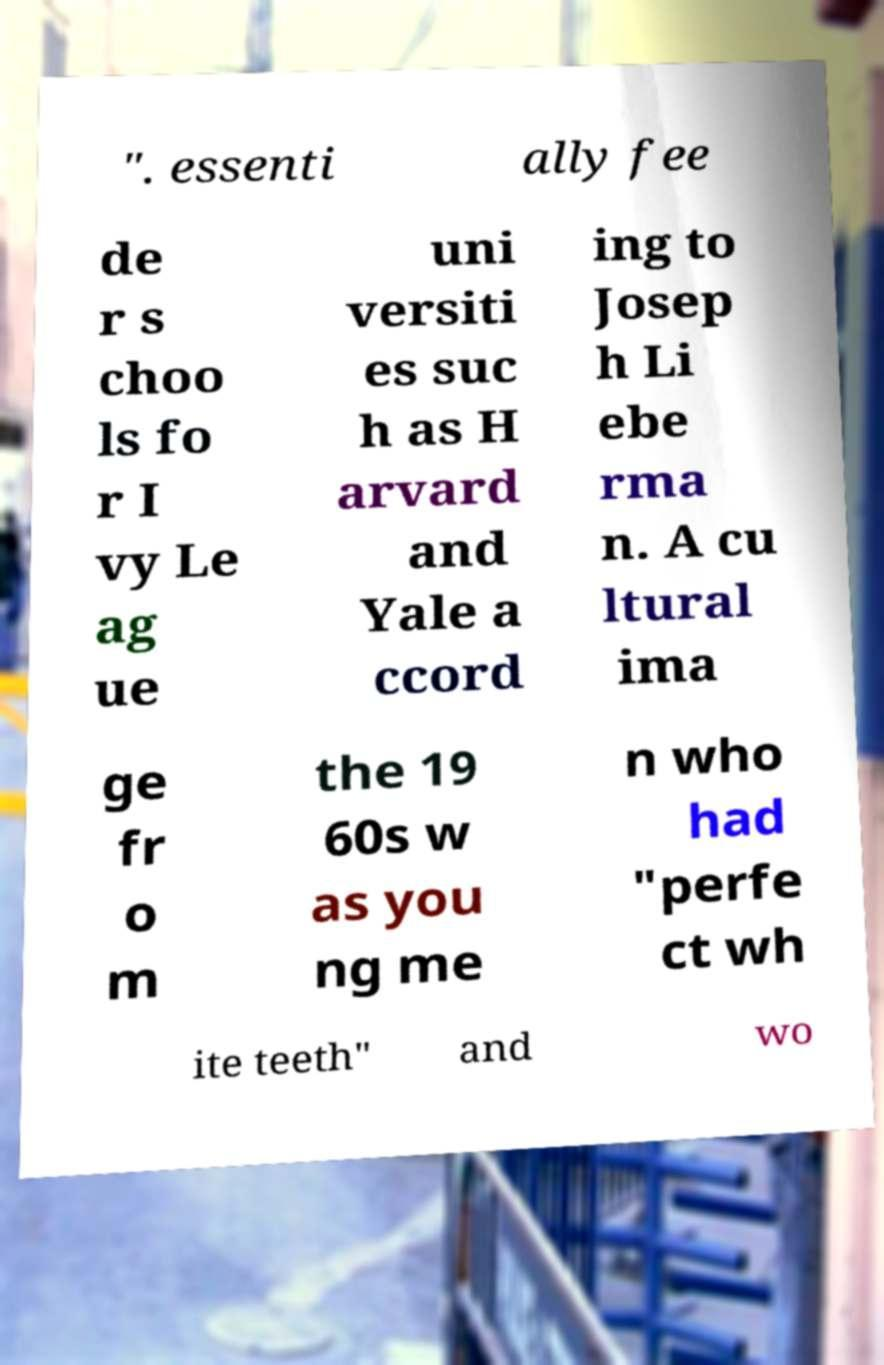Can you accurately transcribe the text from the provided image for me? ". essenti ally fee de r s choo ls fo r I vy Le ag ue uni versiti es suc h as H arvard and Yale a ccord ing to Josep h Li ebe rma n. A cu ltural ima ge fr o m the 19 60s w as you ng me n who had "perfe ct wh ite teeth" and wo 